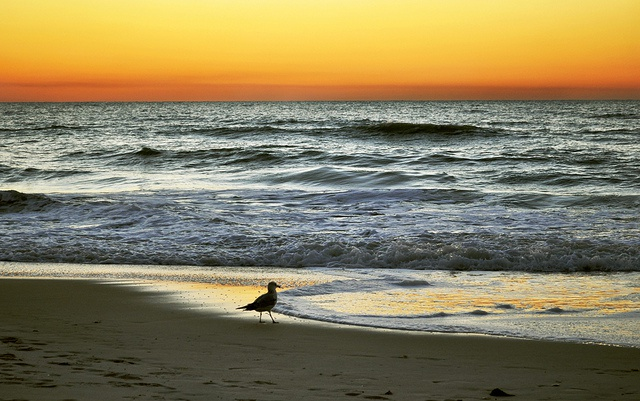Describe the objects in this image and their specific colors. I can see a bird in khaki, black, gray, and tan tones in this image. 